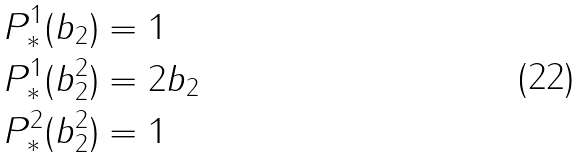<formula> <loc_0><loc_0><loc_500><loc_500>P ^ { 1 } _ { * } ( b _ { 2 } ) & = 1 \\ P ^ { 1 } _ { * } ( b _ { 2 } ^ { 2 } ) & = 2 b _ { 2 } \\ P ^ { 2 } _ { * } ( b _ { 2 } ^ { 2 } ) & = 1</formula> 